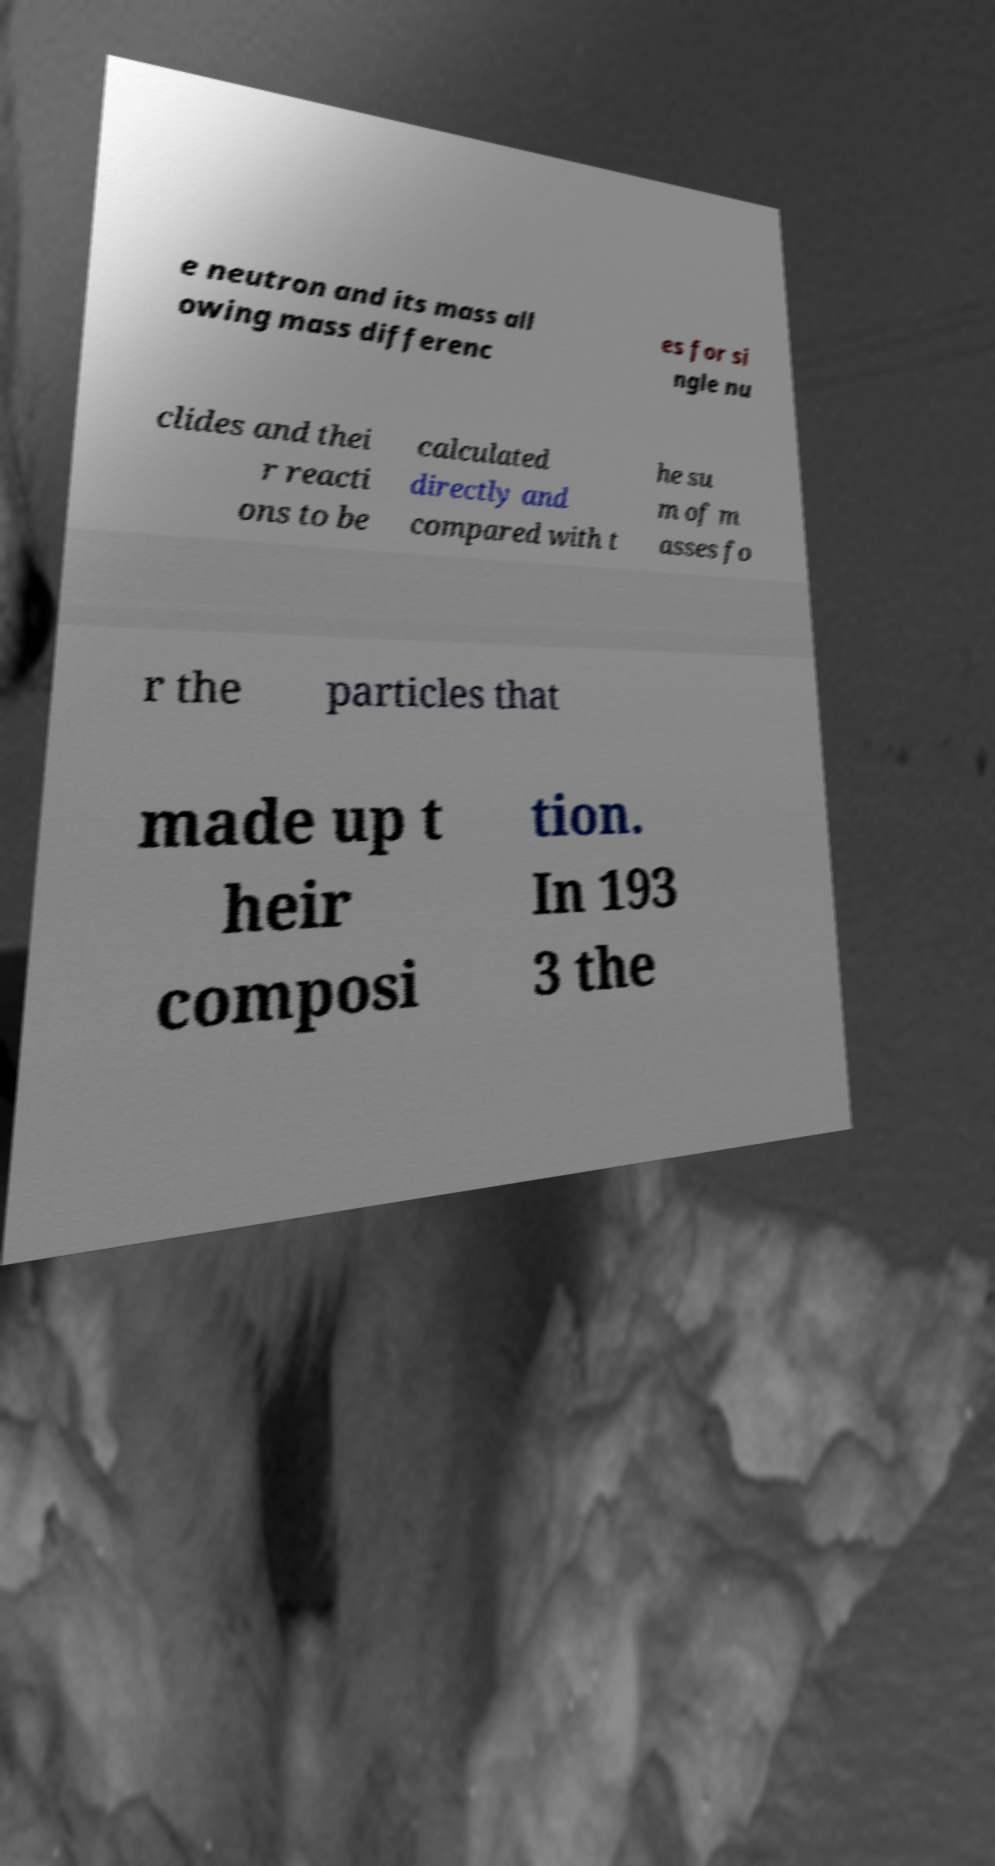I need the written content from this picture converted into text. Can you do that? e neutron and its mass all owing mass differenc es for si ngle nu clides and thei r reacti ons to be calculated directly and compared with t he su m of m asses fo r the particles that made up t heir composi tion. In 193 3 the 